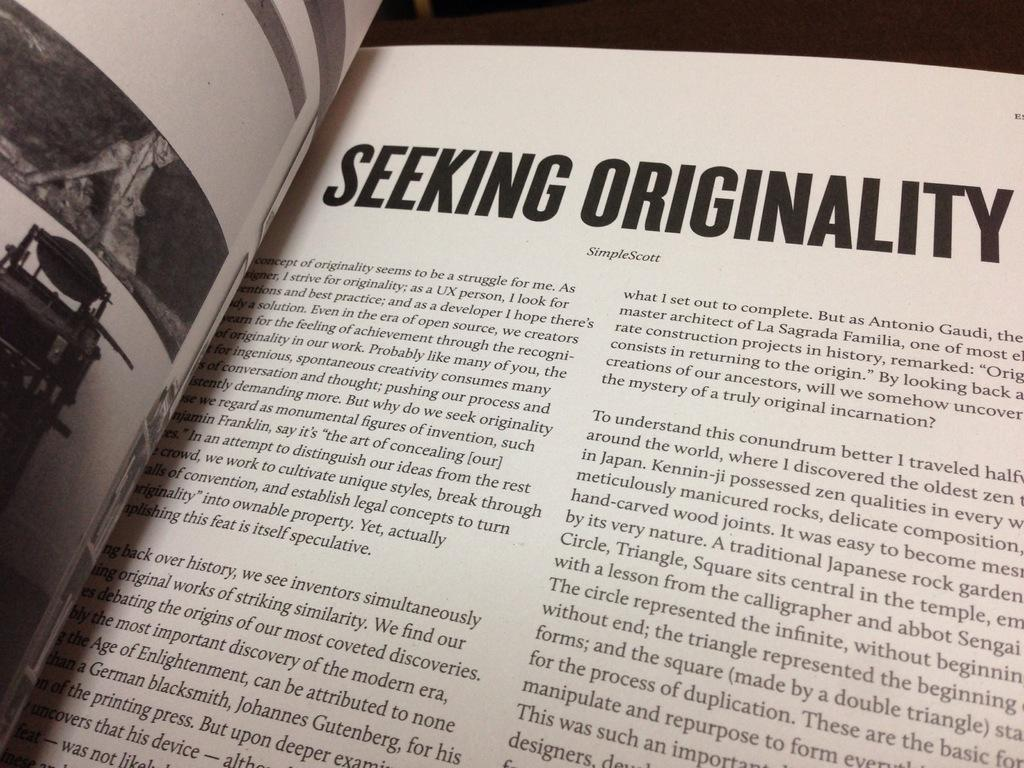<image>
Summarize the visual content of the image. A book opened to a page with Seeking originality written on it. 